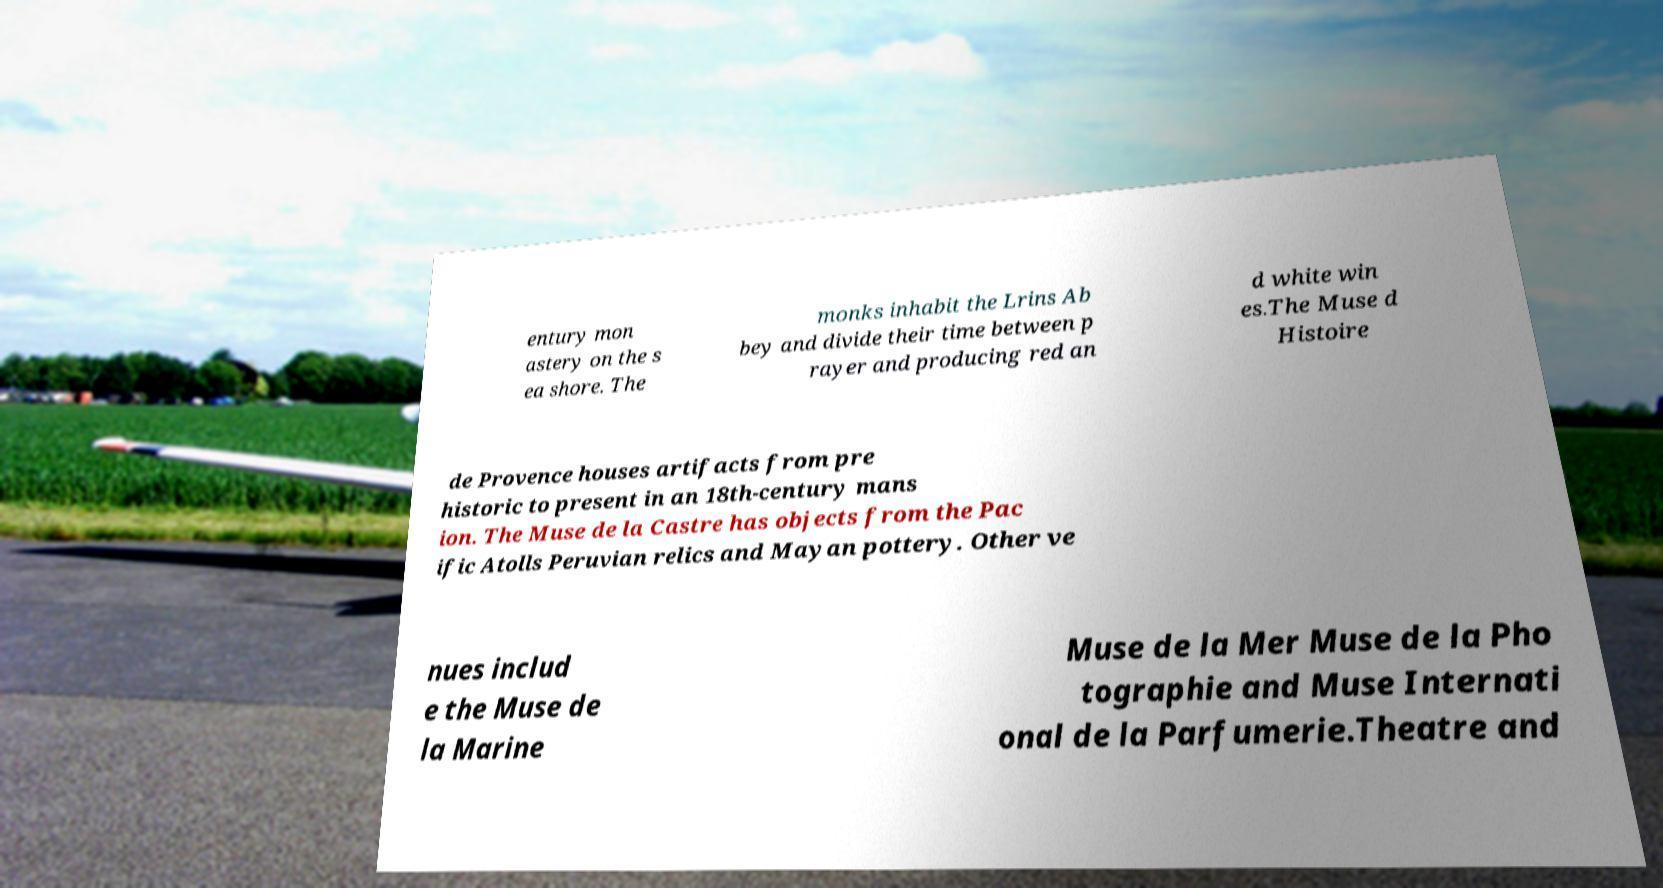Please read and relay the text visible in this image. What does it say? entury mon astery on the s ea shore. The monks inhabit the Lrins Ab bey and divide their time between p rayer and producing red an d white win es.The Muse d Histoire de Provence houses artifacts from pre historic to present in an 18th-century mans ion. The Muse de la Castre has objects from the Pac ific Atolls Peruvian relics and Mayan pottery. Other ve nues includ e the Muse de la Marine Muse de la Mer Muse de la Pho tographie and Muse Internati onal de la Parfumerie.Theatre and 